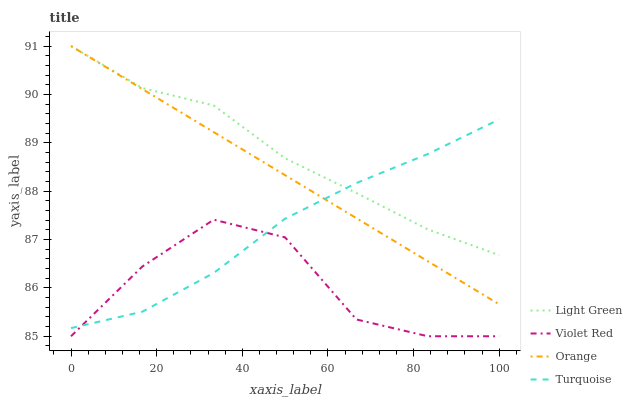Does Violet Red have the minimum area under the curve?
Answer yes or no. Yes. Does Light Green have the maximum area under the curve?
Answer yes or no. Yes. Does Turquoise have the minimum area under the curve?
Answer yes or no. No. Does Turquoise have the maximum area under the curve?
Answer yes or no. No. Is Orange the smoothest?
Answer yes or no. Yes. Is Violet Red the roughest?
Answer yes or no. Yes. Is Turquoise the smoothest?
Answer yes or no. No. Is Turquoise the roughest?
Answer yes or no. No. Does Violet Red have the lowest value?
Answer yes or no. Yes. Does Turquoise have the lowest value?
Answer yes or no. No. Does Light Green have the highest value?
Answer yes or no. Yes. Does Turquoise have the highest value?
Answer yes or no. No. Is Violet Red less than Light Green?
Answer yes or no. Yes. Is Orange greater than Violet Red?
Answer yes or no. Yes. Does Orange intersect Turquoise?
Answer yes or no. Yes. Is Orange less than Turquoise?
Answer yes or no. No. Is Orange greater than Turquoise?
Answer yes or no. No. Does Violet Red intersect Light Green?
Answer yes or no. No. 